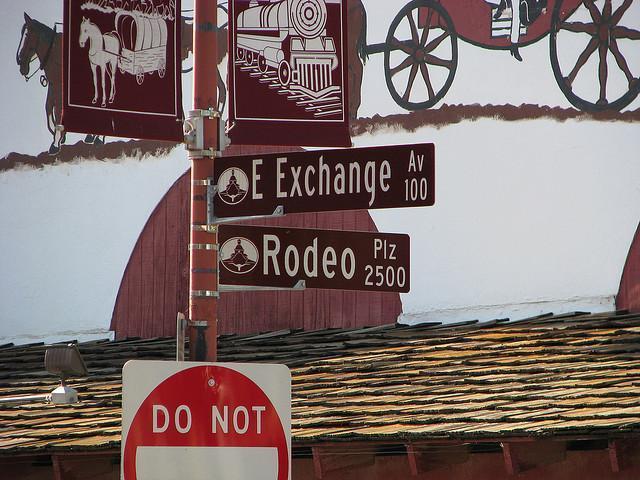How many pizza slices are missing from the tray?
Give a very brief answer. 0. 